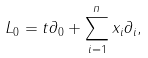Convert formula to latex. <formula><loc_0><loc_0><loc_500><loc_500>L _ { 0 } = t \partial _ { 0 } + \sum ^ { n } _ { i = 1 } x _ { i } \partial _ { i } ,</formula> 